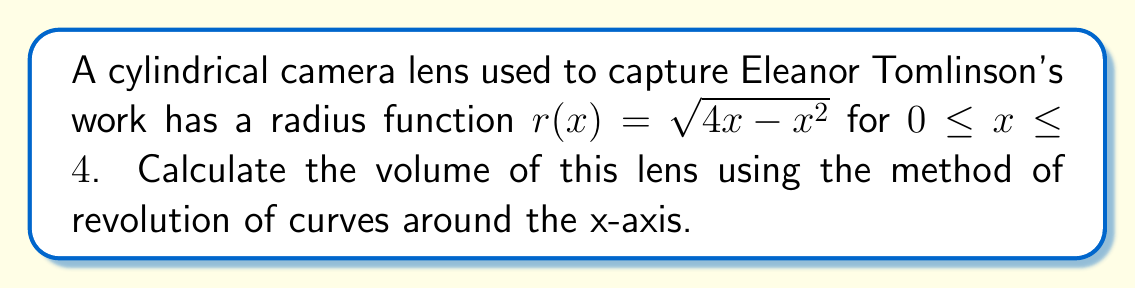Show me your answer to this math problem. To calculate the volume of the cylindrical lens using revolution of curves, we'll follow these steps:

1) The volume of a solid formed by revolving a curve $y = f(x)$ around the x-axis from $x = a$ to $x = b$ is given by:

   $$V = \pi \int_a^b [f(x)]^2 dx$$

2) In our case, $r(x) = \sqrt{4x - x^2}$, $a = 0$, and $b = 4$. So our integral becomes:

   $$V = \pi \int_0^4 (4x - x^2) dx$$

3) Let's expand and integrate:

   $$V = \pi \int_0^4 (4x - x^2) dx = \pi \left[2x^2 - \frac{1}{3}x^3\right]_0^4$$

4) Evaluate the integral:

   $$V = \pi \left[(2(4)^2 - \frac{1}{3}(4)^3) - (2(0)^2 - \frac{1}{3}(0)^3)\right]$$
   
   $$V = \pi \left[32 - \frac{64}{3} - 0\right] = \pi \left[\frac{96}{3} - \frac{64}{3}\right] = \pi \cdot \frac{32}{3}$$

5) Simplify:

   $$V = \frac{32\pi}{3} \text{ cubic units}$$
Answer: $\frac{32\pi}{3}$ cubic units 